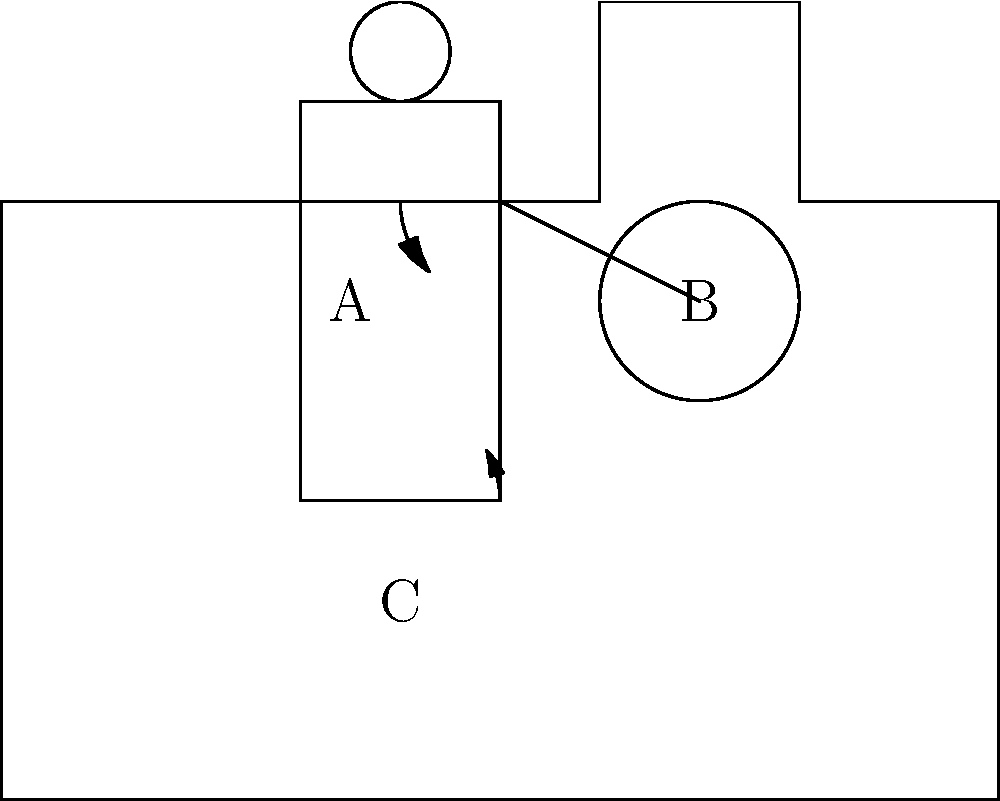In the diagram of a tractor operator, which labeled point represents the area of highest muscle engagement during prolonged operation, and what ergonomic adjustment could be made to reduce strain? To answer this question, let's analyze the three labeled points and their implications for muscle engagement and ergonomics:

1. Point A: This represents the lower back area of the operator. During prolonged sitting, this area can experience significant strain due to poor posture and lack of lumbar support.

2. Point B: This represents the arms and shoulders, which are engaged in steering. While this area does experience some strain, it's generally not as severe as other areas if the steering wheel is properly positioned.

3. Point C: This represents the legs and hips. In a tractor, the legs are often in a fixed position for extended periods, which can lead to circulation issues and muscle fatigue.

Among these, Point A (lower back) typically experiences the highest muscle engagement and strain during prolonged tractor operation. This is because:

- The seated position puts pressure on the lower back
- Lack of proper lumbar support can lead to poor posture
- Vibrations from the tractor can amplify stress on the spine

To reduce strain at this point, an ergonomic adjustment could be made by adding lumbar support to the seat. This would help maintain the natural curve of the spine, reducing muscle engagement and preventing fatigue.

Other potential ergonomic improvements could include:
- Adjustable seat positioning
- Vibration dampening systems
- Periodic breaks to stretch and move around

However, the most immediate and effective ergonomic adjustment for the area of highest muscle engagement (Point A) would be adding lumbar support.
Answer: Point A; Add lumbar support to the seat 